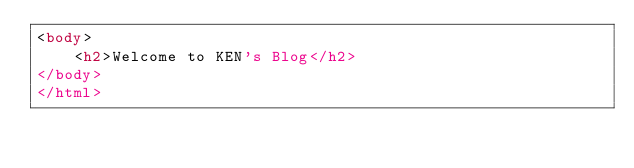<code> <loc_0><loc_0><loc_500><loc_500><_HTML_><body>
    <h2>Welcome to KEN's Blog</h2>
</body>
</html></code> 